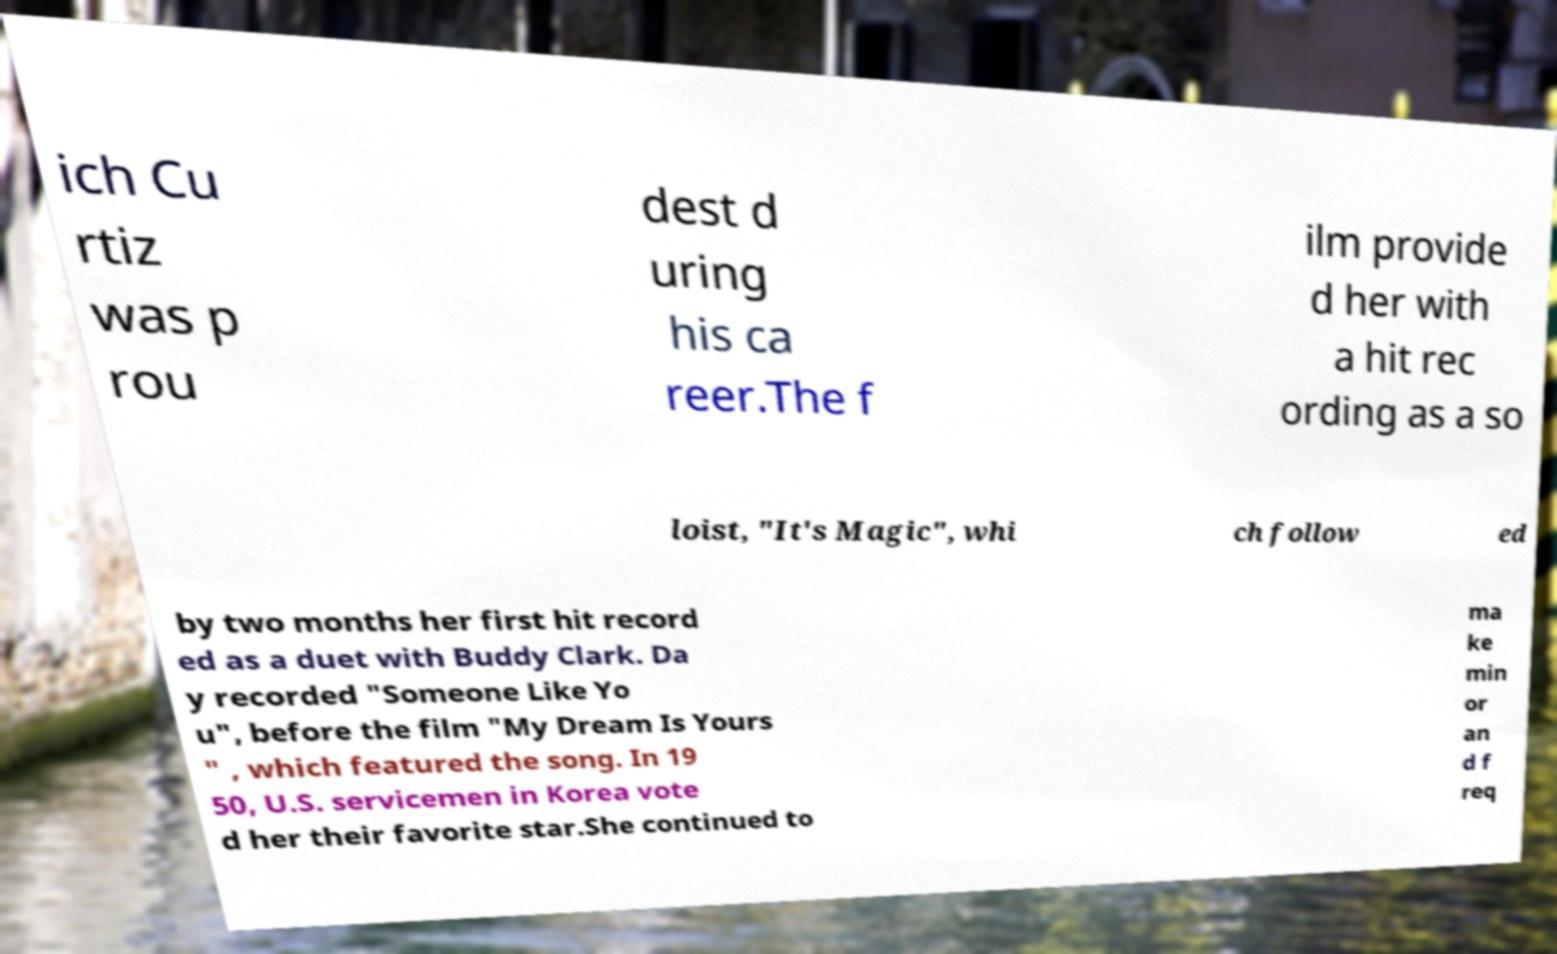Could you extract and type out the text from this image? ich Cu rtiz was p rou dest d uring his ca reer.The f ilm provide d her with a hit rec ording as a so loist, "It's Magic", whi ch follow ed by two months her first hit record ed as a duet with Buddy Clark. Da y recorded "Someone Like Yo u", before the film "My Dream Is Yours " , which featured the song. In 19 50, U.S. servicemen in Korea vote d her their favorite star.She continued to ma ke min or an d f req 